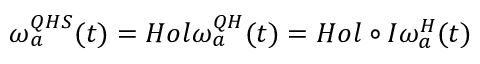<formula> <loc_0><loc_0><loc_500><loc_500>\omega _ { a } ^ { Q H S } ( t ) = H o l \omega _ { a } ^ { Q H } ( t ) = H o l \circ I \omega _ { a } ^ { H } ( t )</formula> 